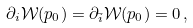Convert formula to latex. <formula><loc_0><loc_0><loc_500><loc_500>\partial _ { i } { \mathcal { W } } ( p _ { 0 } ) = \partial _ { \bar { i } } { \mathcal { W } } ( p _ { 0 } ) = 0 \, ,</formula> 